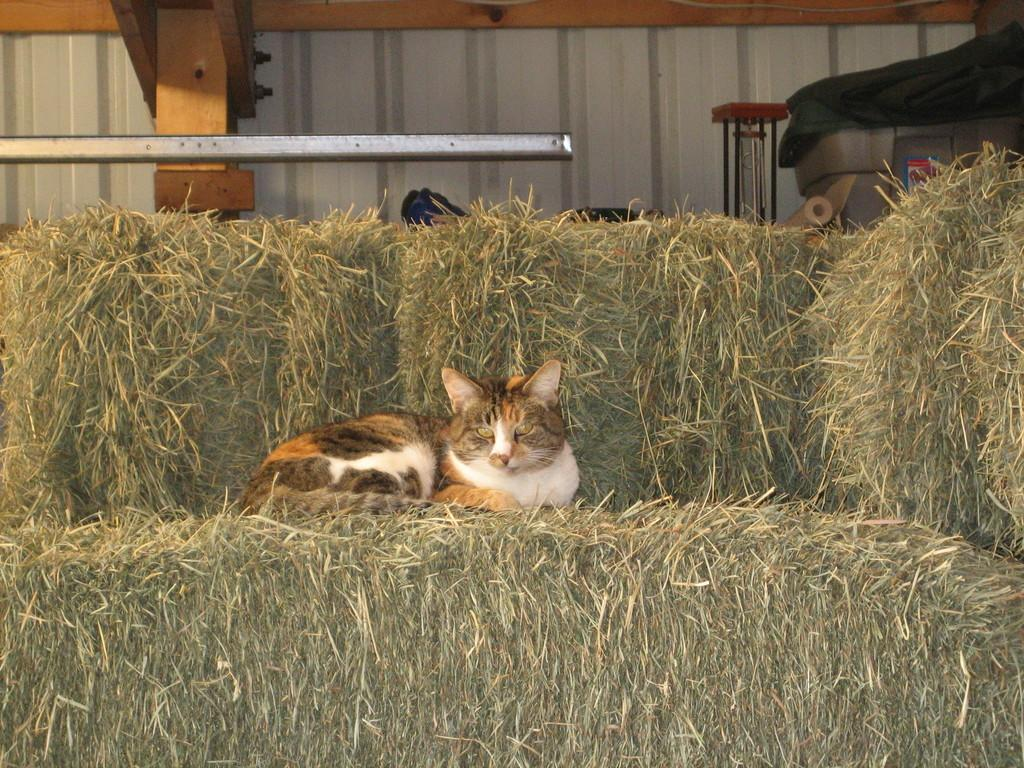What animal is sitting on the dried grass in the image? There is a cat sitting on the dried grass in the image. What else can be seen in the area besides the cat? There are objects placed in the area. What type of material is covering the ground in the image? The area appears to have an iron sheet. Can you identify any architectural features in the image? Yes, there is a pillar visible in the image. What type of office furniture can be seen in the image? There is no office furniture present in the image; it features a cat sitting on dried grass, objects placed in the area, an iron sheet, and a pillar. 